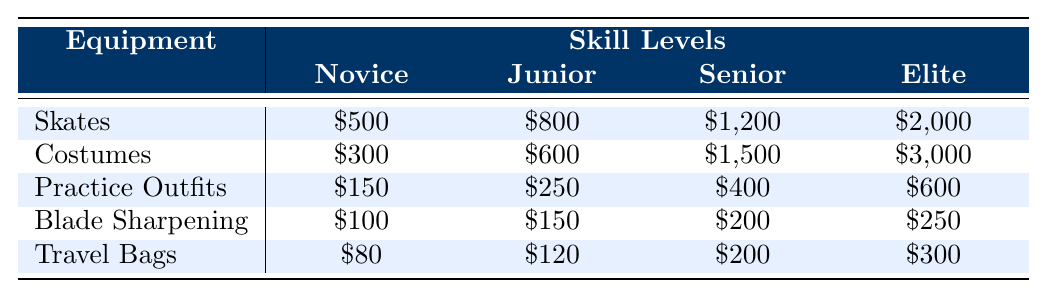What is the cost of skates for Junior level dancers? According to the table, the cost of skates for Junior level dancers is listed as $800.
Answer: $800 Which equipment costs the least for Novice level dancers? The table shows that for Novice level dancers, the cheapest equipment is blade sharpening, which costs $100.
Answer: Blade Sharpening What is the total cost of costumes for Elite level dancers compared to Novice level dancers? For Elite level dancers, costumes cost $3,000 while for Novice level dancers they cost $300. The difference is $3,000 - $300 = $2,700.
Answer: $2,700 How much more do Elite level dancers spend on practice outfits than Novice level dancers? The cost of practice outfits for Elite level dancers is $600, while for Novice level dancers it is $150. The difference is $600 - $150 = $450.
Answer: $450 Is the cost of travel bags for Senior level dancers greater than the cost of blade sharpening for Novice level dancers? The cost of travel bags for Senior level dancers is $200, and the cost of blade sharpening for Novice level dancers is $100. Since $200 is greater than $100, the statement is true.
Answer: Yes What is the average cost of costumes across all skill levels? The costs of costumes are $300 (Novice), $600 (Junior), $1,500 (Senior), and $3,000 (Elite). The total is $300 + $600 + $1,500 + $3,000 = $5,400. There are 4 data points, so the average is $5,400 / 4 = $1,350.
Answer: $1,350 Which piece of equipment shows the largest increase in price from Junior to Elite level? For Junior level dancers, the costs for skates, costumes, practice outfits, blade sharpening, and travel bags are $800, $600, $250, $150, and $120 respectively. For Elite level dancers, they are $2,000, $3,000, $600, $250, and $300 respectively. The largest increase is in costumes, from $600 to $3,000, which is a difference of $2,400.
Answer: Costumes What is the total annual cost for blades sharpening for Elite level dancers assuming the annual replacement rate? The cost of blade sharpening for Elite level dancers is $250, and the annual replacement rate is 12. Therefore, the total annual cost for blade sharpening is $250 * 12 = $3,000.
Answer: $3,000 How does the cost of Junior level skates compare with the total cost of travel bags for Elite level dancers? The cost of skates for Junior level dancers is $800 and the cost of travel bags for Elite level dancers is $300. The Junior skates are $800, which is greater than $300 for travel bags.
Answer: Junior skates are more expensive If an Elite level dancer needs to replace their costumes annually, what will be their annual expense for costumes? The cost of costumes for Elite level dancers is $3,000, and they need to replace them twice a year according to the replacement rate. Thus, the annual expense is $3,000 * 2 = $6,000.
Answer: $6,000 